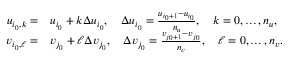Convert formula to latex. <formula><loc_0><loc_0><loc_500><loc_500>\begin{array} { r l } { u _ { i _ { 0 } , k } = } & { u _ { i _ { 0 } } + k \Delta u _ { i _ { 0 } } , \quad \Delta u _ { i _ { 0 } } = \frac { u _ { i _ { 0 } + 1 } - u _ { i _ { 0 } } } { n _ { u } } , \quad k = 0 , \dots , n _ { u } , } \\ { v _ { i _ { 0 } , \ell } = } & { v _ { j _ { 0 } } + \ell \Delta v _ { j _ { 0 } } , \quad \Delta v _ { j _ { 0 } } = \frac { v _ { j _ { 0 } + 1 } - v _ { j _ { 0 } } } { n _ { v } } , \quad \ell = 0 , \dots , n _ { v } . } \end{array}</formula> 